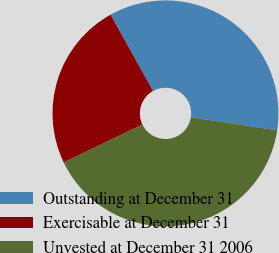<chart> <loc_0><loc_0><loc_500><loc_500><pie_chart><fcel>Outstanding at December 31<fcel>Exercisable at December 31<fcel>Unvested at December 31 2006<nl><fcel>35.47%<fcel>24.07%<fcel>40.46%<nl></chart> 